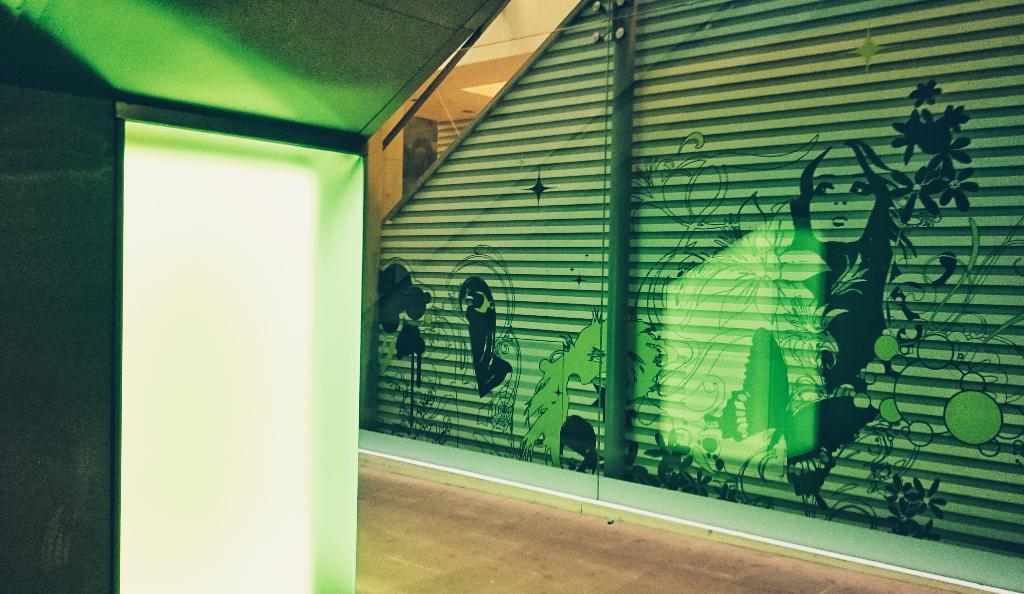What is hanging on the wall in the image? There is a painting on the wall in the image. What object can be seen in the image that is typically used for drinking? There is a glass in the image. How many snails are crawling on the painting in the image? There are no snails present in the image; it only features a painting on the wall. What religious symbol can be seen in the image? There is no religious symbol present in the image; it only features a painting on the wall and a glass. 